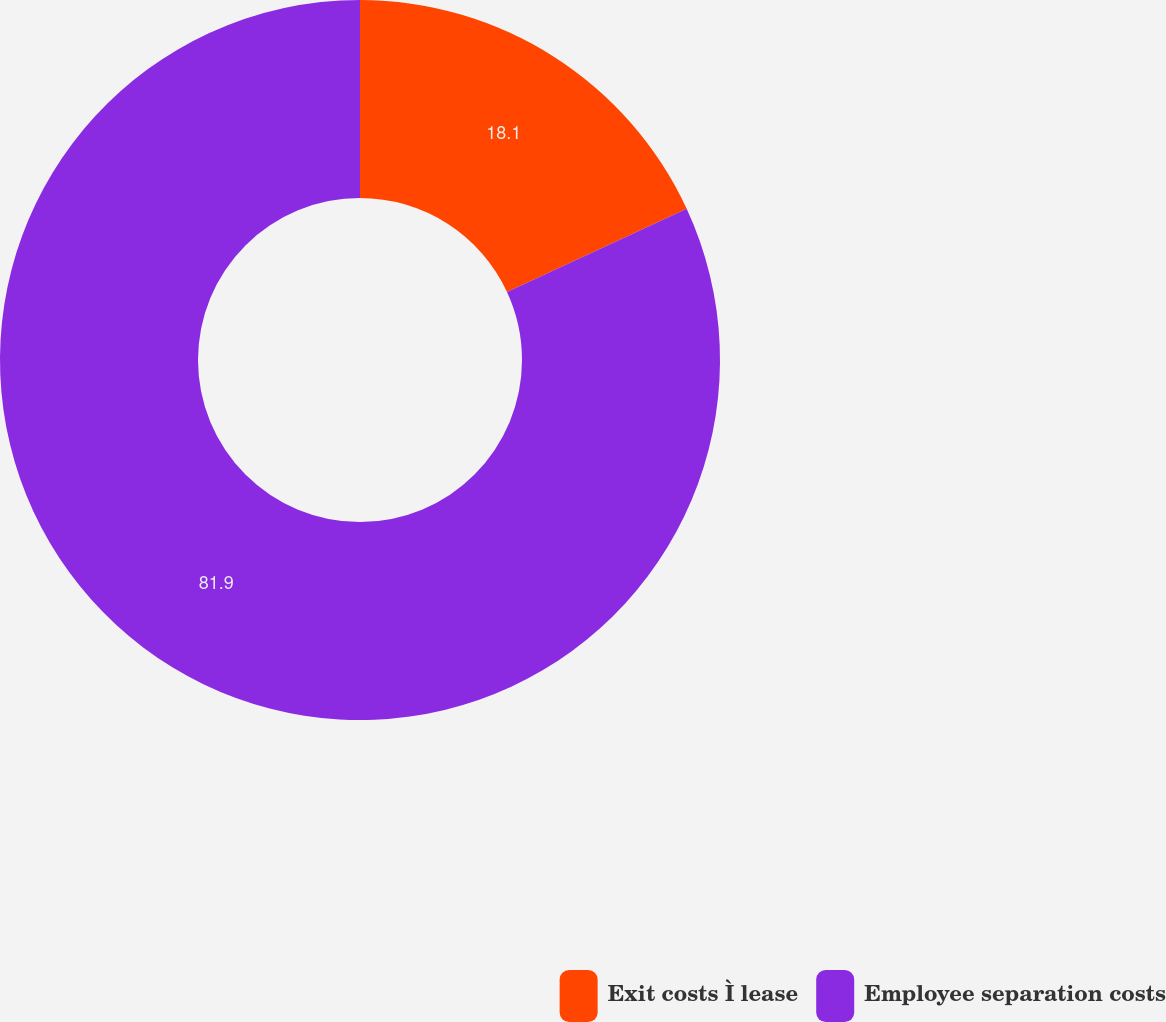Convert chart to OTSL. <chart><loc_0><loc_0><loc_500><loc_500><pie_chart><fcel>Exit costs Ì lease<fcel>Employee separation costs<nl><fcel>18.1%<fcel>81.9%<nl></chart> 